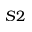Convert formula to latex. <formula><loc_0><loc_0><loc_500><loc_500>S 2</formula> 